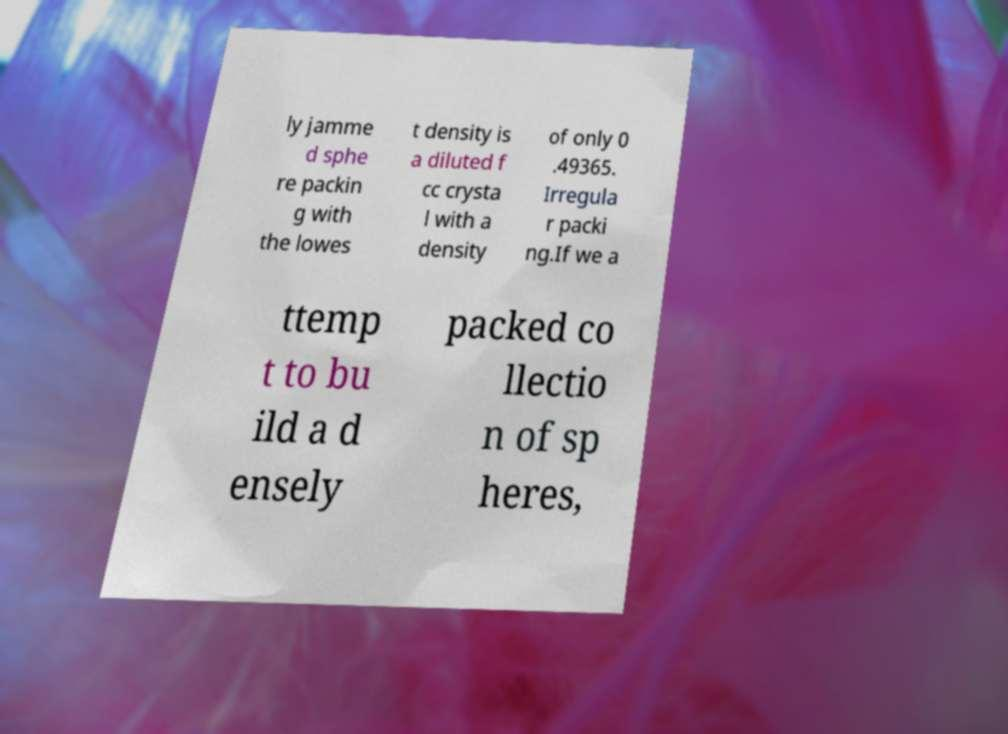There's text embedded in this image that I need extracted. Can you transcribe it verbatim? ly jamme d sphe re packin g with the lowes t density is a diluted f cc crysta l with a density of only 0 .49365. Irregula r packi ng.If we a ttemp t to bu ild a d ensely packed co llectio n of sp heres, 